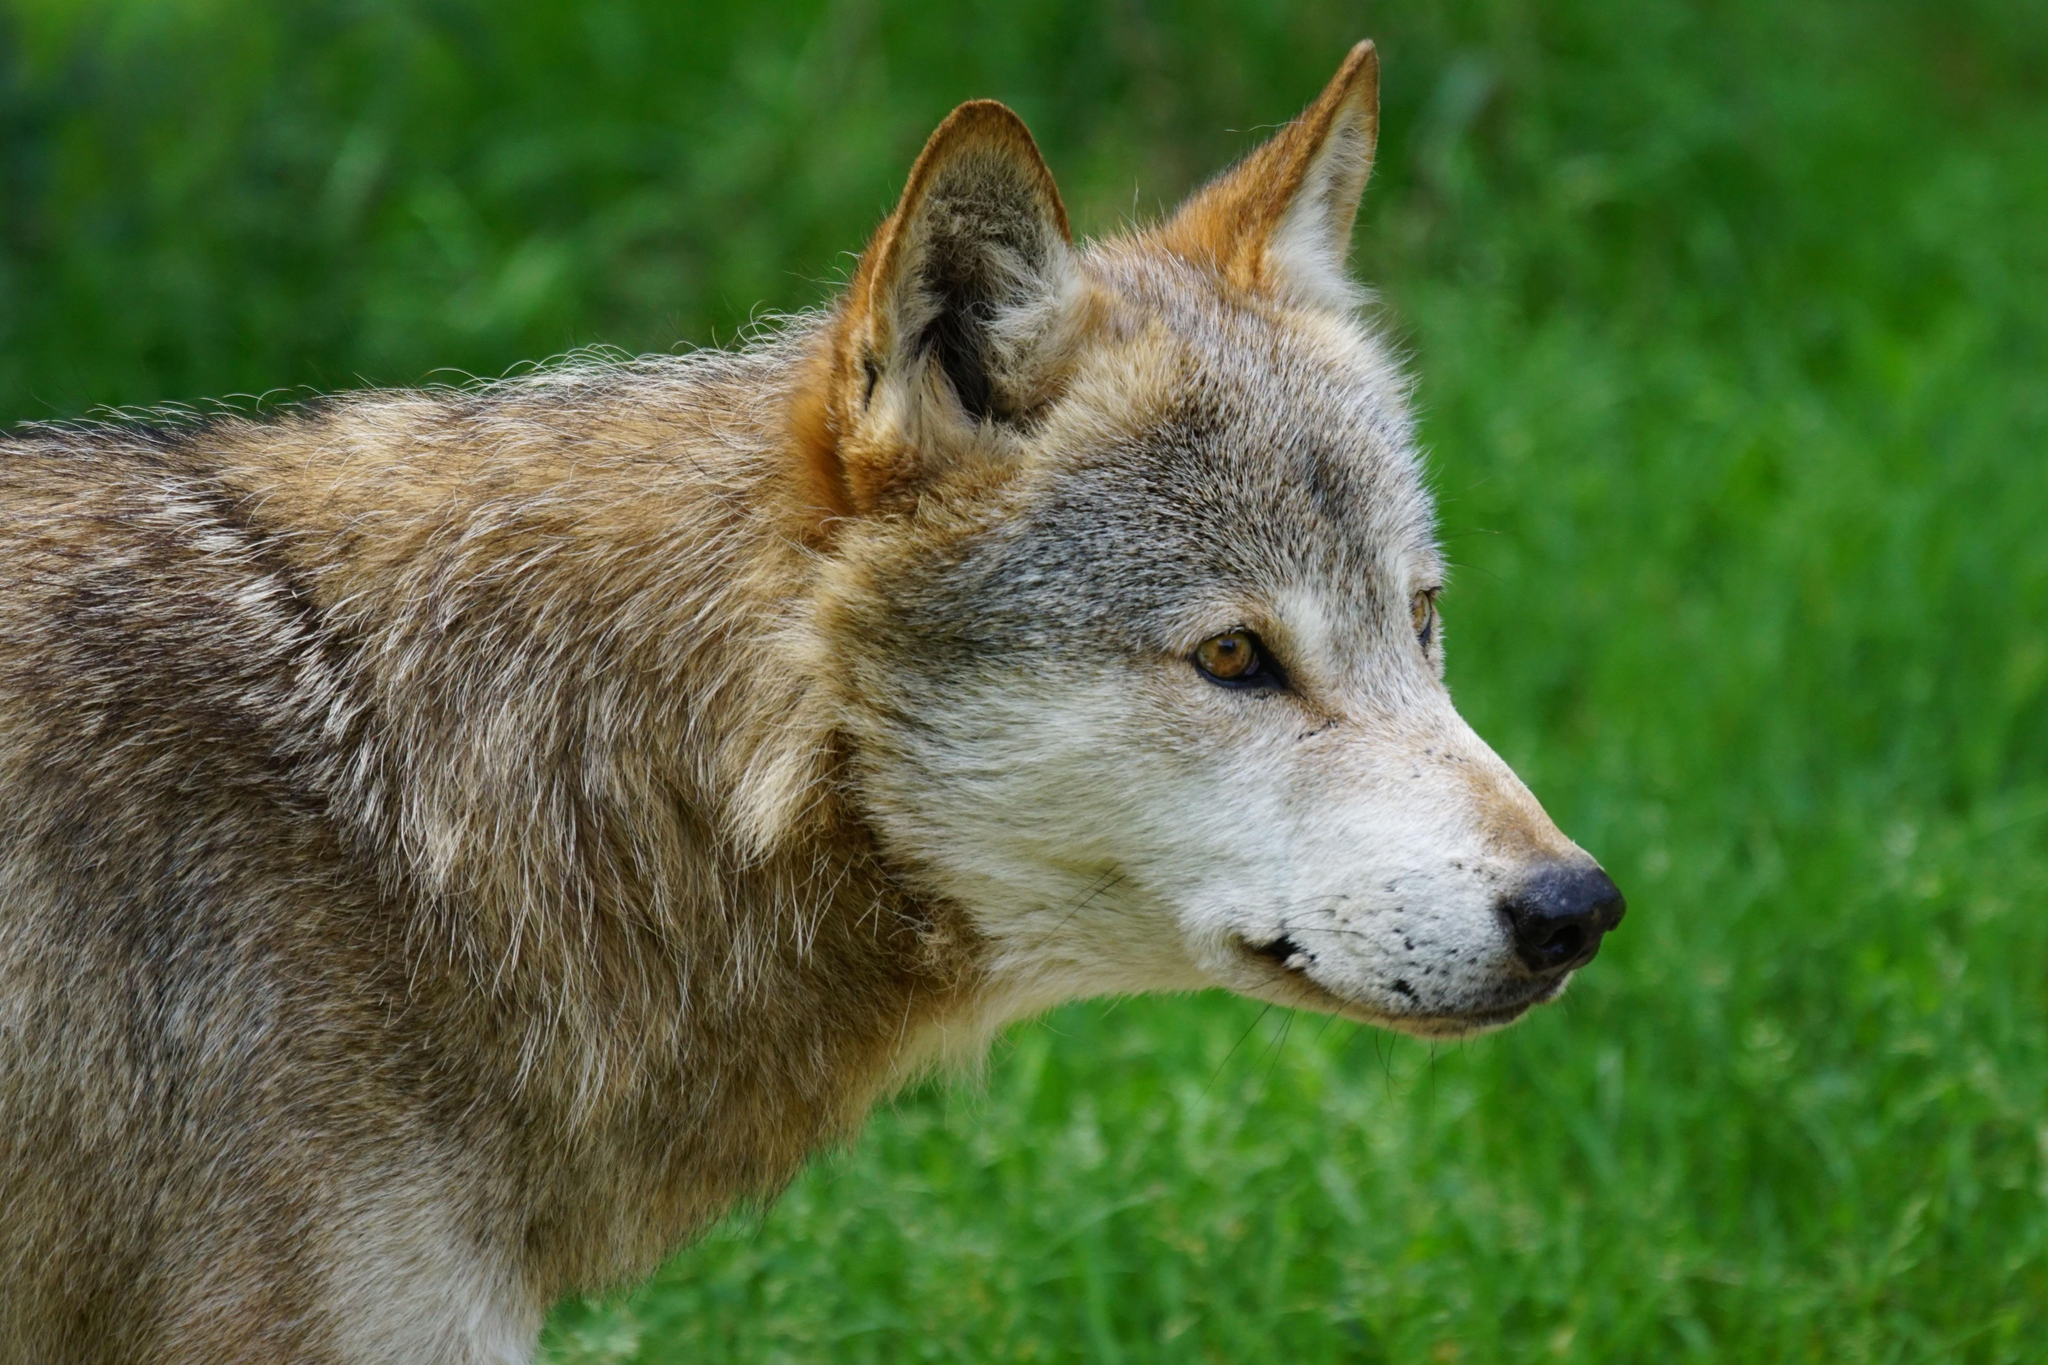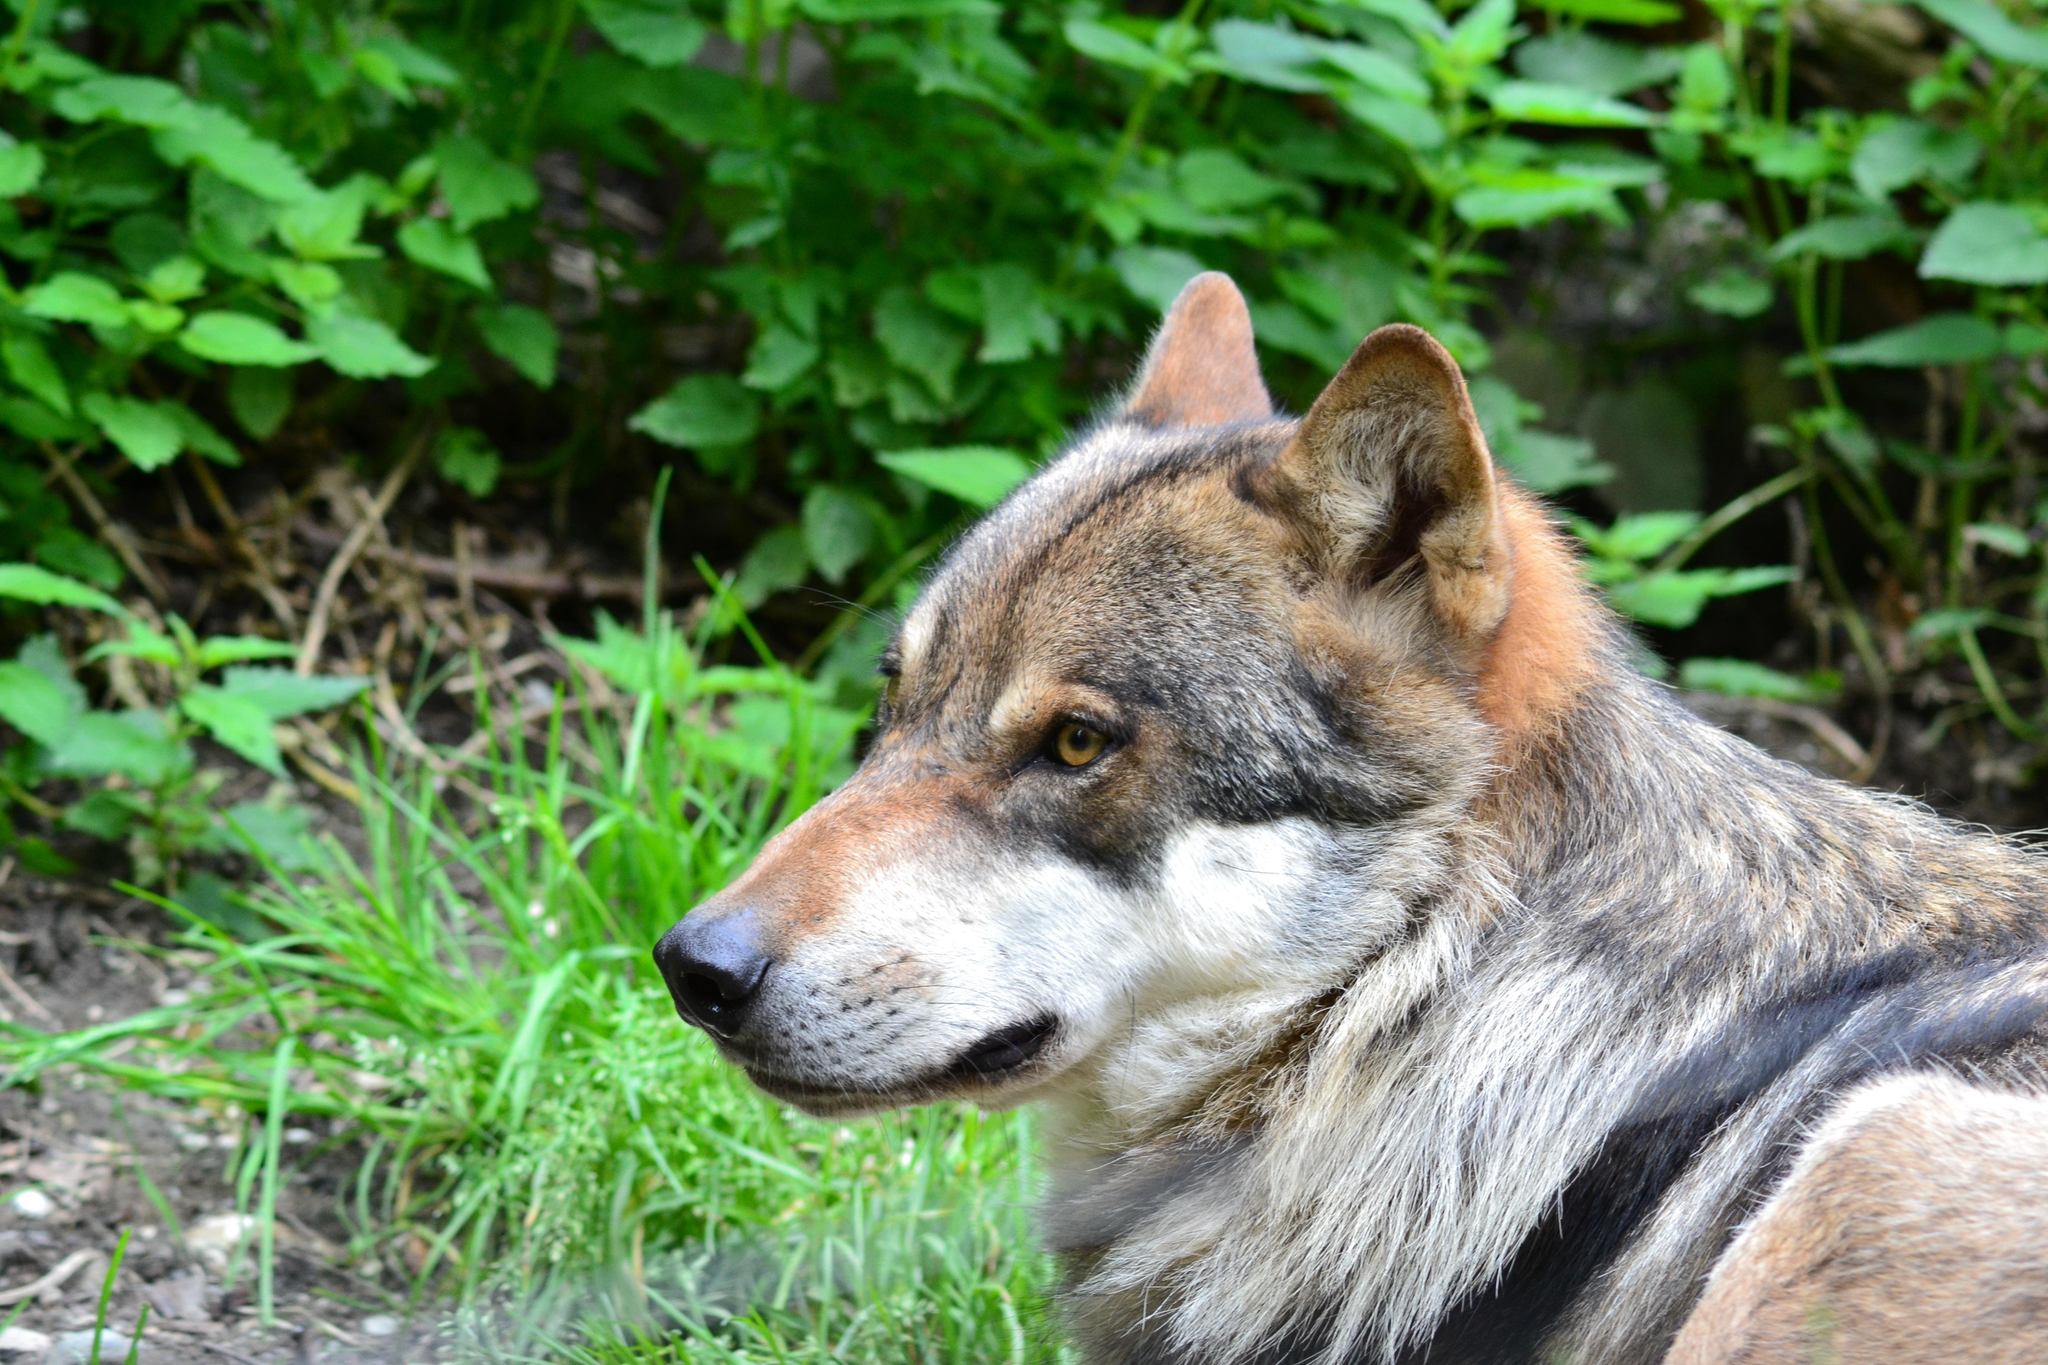The first image is the image on the left, the second image is the image on the right. For the images displayed, is the sentence "Each image contains one open-eyed dog, and the dogs in the left and right images appear to look toward each other." factually correct? Answer yes or no. Yes. The first image is the image on the left, the second image is the image on the right. Considering the images on both sides, is "There are two dogs in grassy areas." valid? Answer yes or no. Yes. 